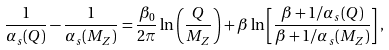<formula> <loc_0><loc_0><loc_500><loc_500>\frac { 1 } { \alpha _ { s } ( Q ) } - \frac { 1 } { \alpha _ { s } ( M _ { Z } ) } = \frac { \beta _ { 0 } } { 2 \pi } \ln \left ( \frac { Q } { M _ { Z } } \right ) + \beta \ln \left [ \frac { \beta + 1 / \alpha _ { s } ( Q ) } { \beta + 1 / \alpha _ { s } ( M _ { Z } ) } \right ] ,</formula> 